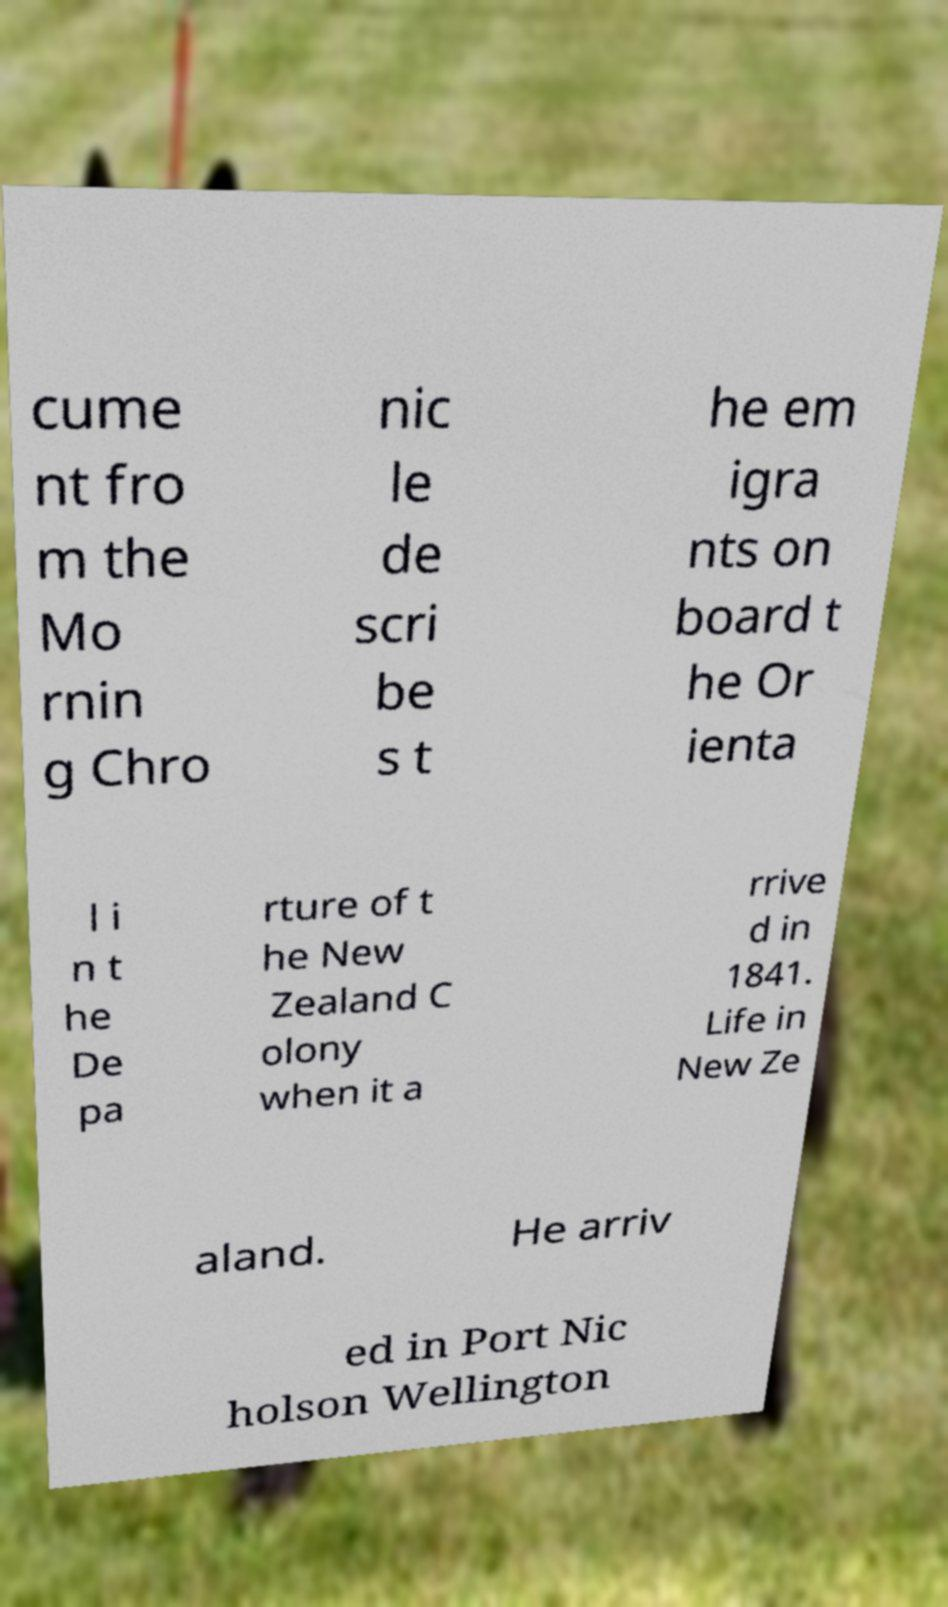What messages or text are displayed in this image? I need them in a readable, typed format. cume nt fro m the Mo rnin g Chro nic le de scri be s t he em igra nts on board t he Or ienta l i n t he De pa rture of t he New Zealand C olony when it a rrive d in 1841. Life in New Ze aland. He arriv ed in Port Nic holson Wellington 